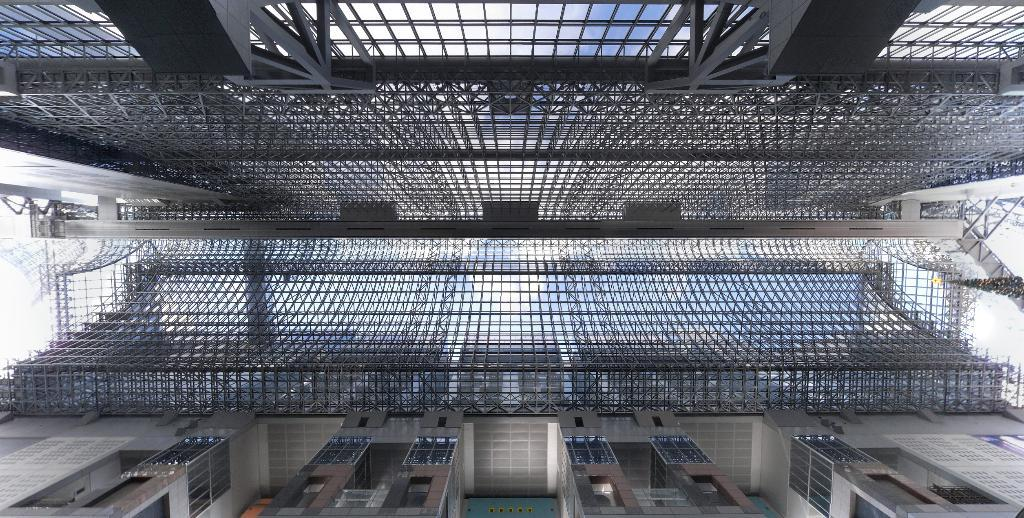What type of structures can be seen in the image? There are buildings in the image. What material is used for the rods in the image? Metal rods are present in the image. What type of plant is visible in the image? There is a tree in the image. What type of oatmeal is being served in the image? A: There is no oatmeal present in the image. What emotion is being expressed by the tree in the image? Trees do not express emotions, so this question cannot be answered. 